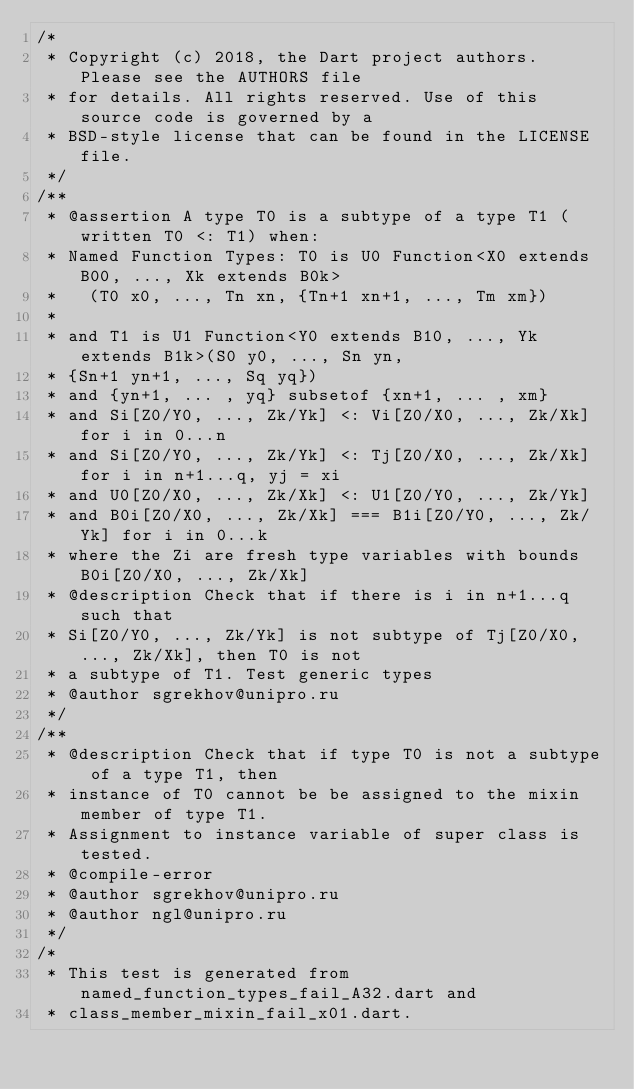Convert code to text. <code><loc_0><loc_0><loc_500><loc_500><_Dart_>/*
 * Copyright (c) 2018, the Dart project authors.  Please see the AUTHORS file
 * for details. All rights reserved. Use of this source code is governed by a
 * BSD-style license that can be found in the LICENSE file.
 */
/**
 * @assertion A type T0 is a subtype of a type T1 (written T0 <: T1) when:
 * Named Function Types: T0 is U0 Function<X0 extends B00, ..., Xk extends B0k>
 *   (T0 x0, ..., Tn xn, {Tn+1 xn+1, ..., Tm xm})
 *
 * and T1 is U1 Function<Y0 extends B10, ..., Yk extends B1k>(S0 y0, ..., Sn yn,
 * {Sn+1 yn+1, ..., Sq yq})
 * and {yn+1, ... , yq} subsetof {xn+1, ... , xm}
 * and Si[Z0/Y0, ..., Zk/Yk] <: Vi[Z0/X0, ..., Zk/Xk] for i in 0...n
 * and Si[Z0/Y0, ..., Zk/Yk] <: Tj[Z0/X0, ..., Zk/Xk] for i in n+1...q, yj = xi
 * and U0[Z0/X0, ..., Zk/Xk] <: U1[Z0/Y0, ..., Zk/Yk]
 * and B0i[Z0/X0, ..., Zk/Xk] === B1i[Z0/Y0, ..., Zk/Yk] for i in 0...k
 * where the Zi are fresh type variables with bounds B0i[Z0/X0, ..., Zk/Xk]
 * @description Check that if there is i in n+1...q such that
 * Si[Z0/Y0, ..., Zk/Yk] is not subtype of Tj[Z0/X0, ..., Zk/Xk], then T0 is not
 * a subtype of T1. Test generic types
 * @author sgrekhov@unipro.ru
 */
/**
 * @description Check that if type T0 is not a subtype of a type T1, then
 * instance of T0 cannot be be assigned to the mixin member of type T1.
 * Assignment to instance variable of super class is tested.
 * @compile-error
 * @author sgrekhov@unipro.ru
 * @author ngl@unipro.ru
 */
/*
 * This test is generated from named_function_types_fail_A32.dart and 
 * class_member_mixin_fail_x01.dart.</code> 